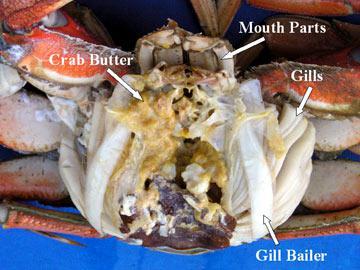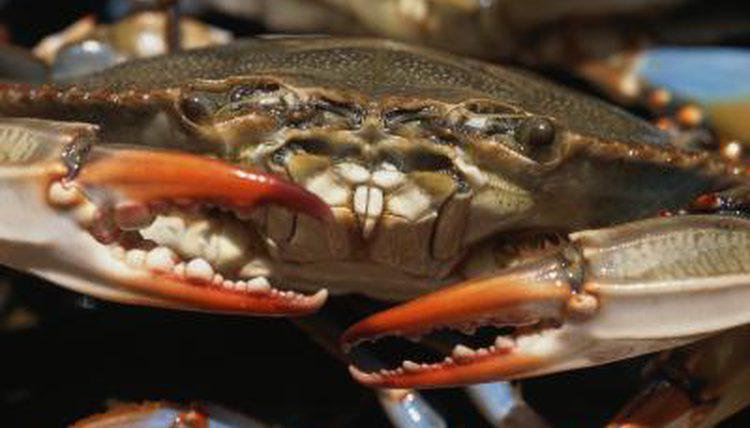The first image is the image on the left, the second image is the image on the right. Examine the images to the left and right. Is the description "Each image includes a crab with a purplish shell looking toward the camera." accurate? Answer yes or no. No. 